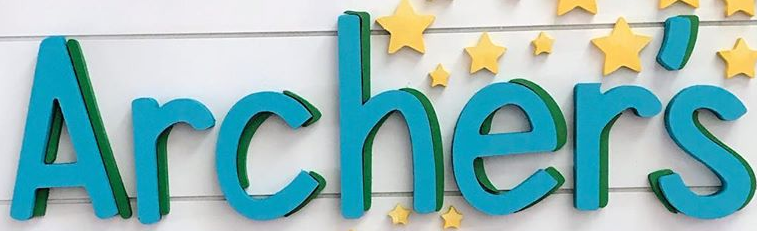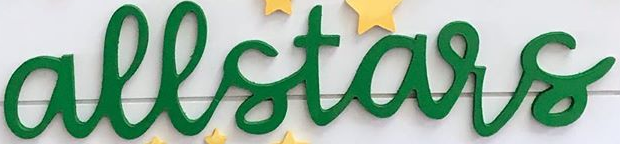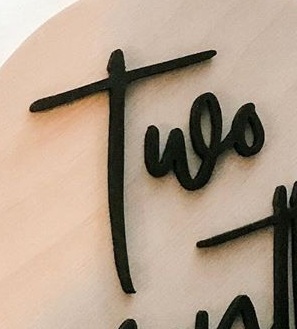Read the text from these images in sequence, separated by a semicolon. Archer's; allstars; Two 